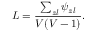<formula> <loc_0><loc_0><loc_500><loc_500>L = \frac { \sum _ { z l } \psi _ { z l } } { V ( V - 1 ) } .</formula> 